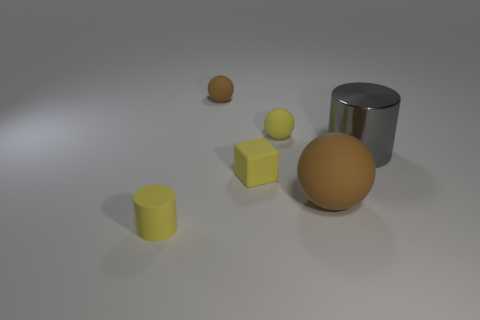What number of other things are the same size as the yellow rubber cylinder?
Offer a very short reply. 3. The yellow object behind the large metal cylinder right of the yellow rubber block is what shape?
Provide a short and direct response. Sphere. Do the cylinder that is in front of the big shiny thing and the cylinder behind the big rubber thing have the same color?
Provide a short and direct response. No. Is there any other thing that is the same color as the tiny matte block?
Your response must be concise. Yes. What color is the tiny matte cylinder?
Give a very brief answer. Yellow. Is there a green metallic cylinder?
Your response must be concise. No. There is a big metallic cylinder; are there any tiny yellow rubber cylinders right of it?
Your answer should be very brief. No. What material is the small yellow object that is the same shape as the big brown rubber object?
Make the answer very short. Rubber. Is there any other thing that is made of the same material as the yellow ball?
Provide a succinct answer. Yes. What number of other things are the same shape as the gray metal object?
Your response must be concise. 1. 